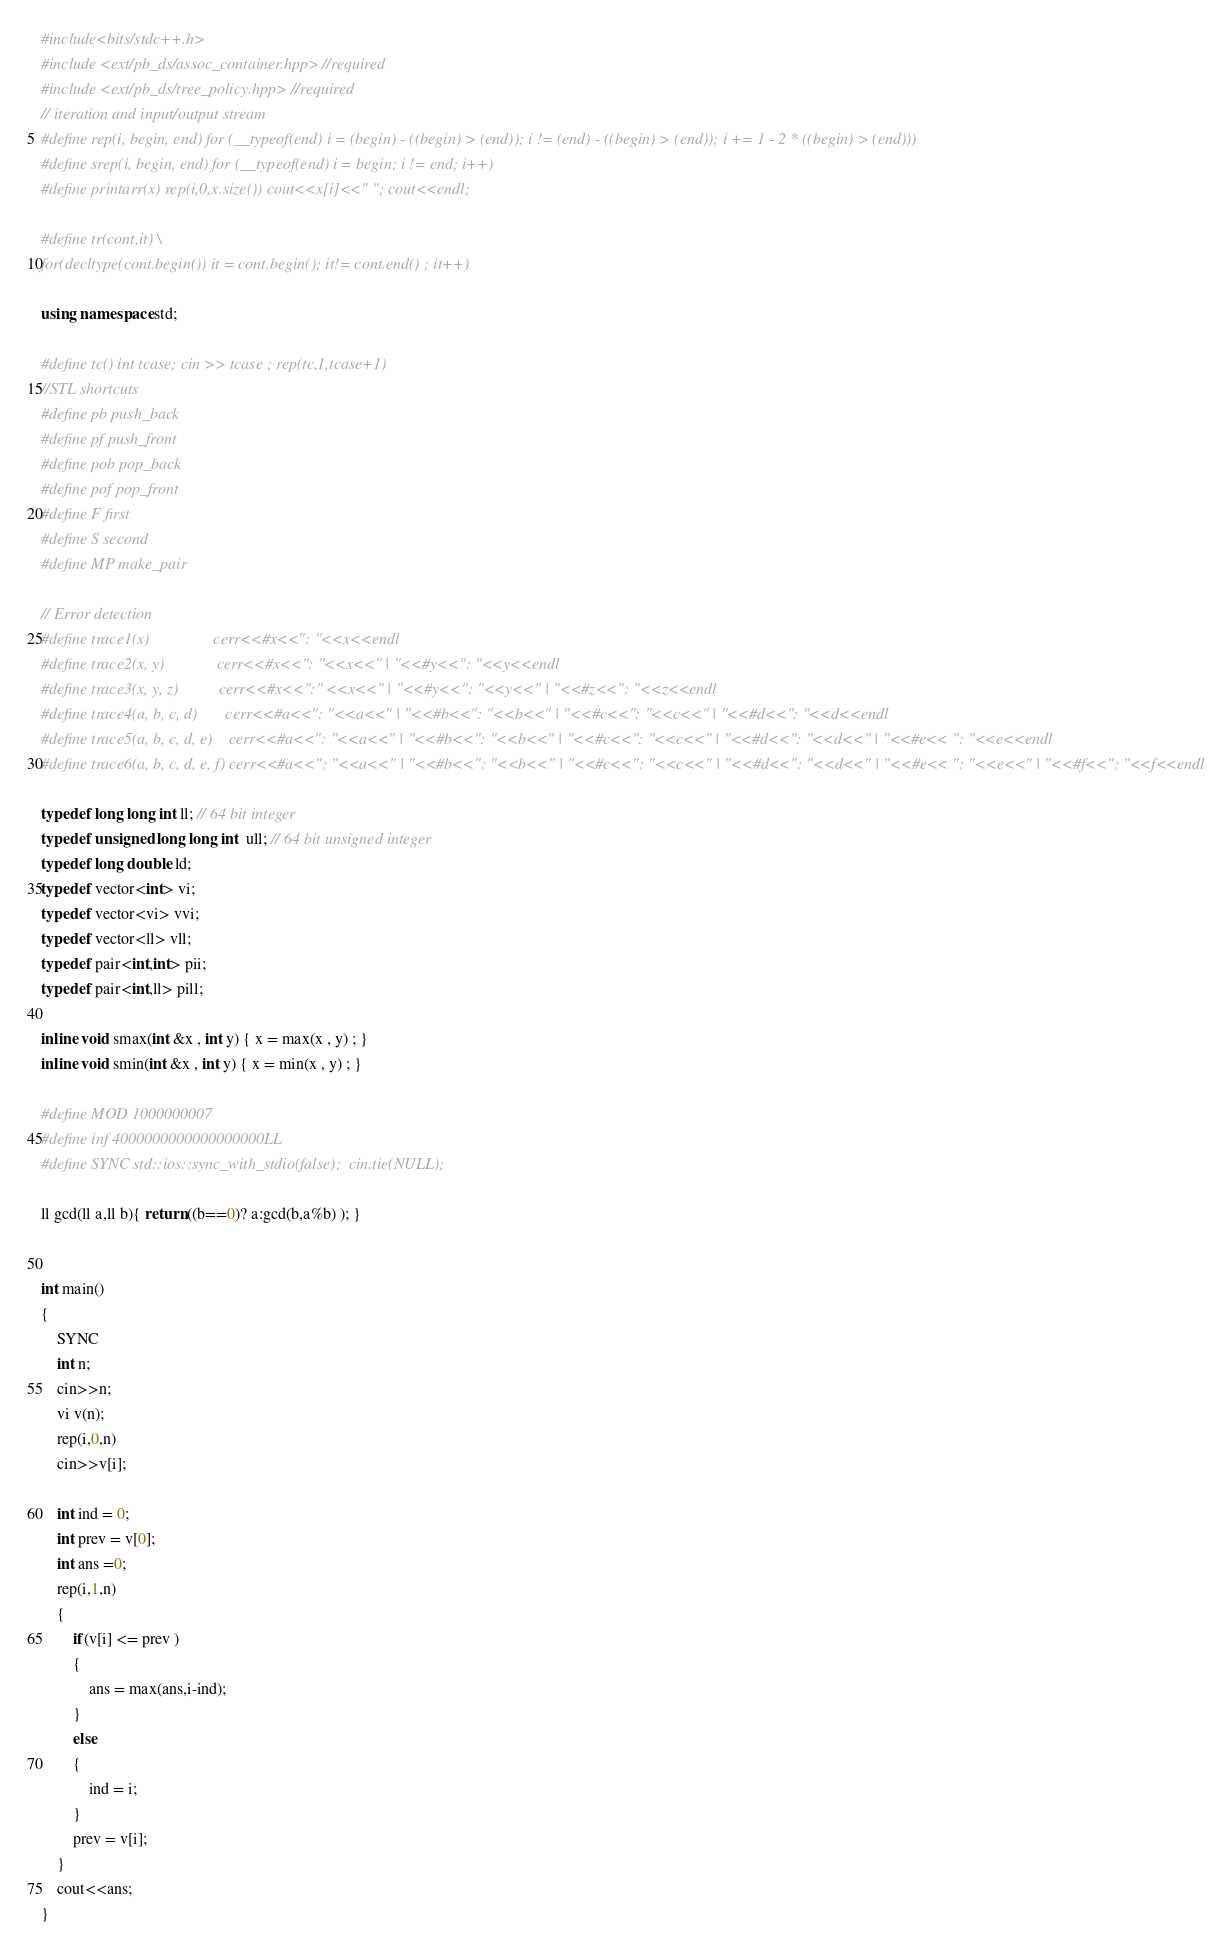<code> <loc_0><loc_0><loc_500><loc_500><_C++_>#include<bits/stdc++.h>
#include <ext/pb_ds/assoc_container.hpp> //required
#include <ext/pb_ds/tree_policy.hpp> //required
// iteration and input/output stream
#define rep(i, begin, end) for (__typeof(end) i = (begin) - ((begin) > (end)); i != (end) - ((begin) > (end)); i += 1 - 2 * ((begin) > (end)))
#define srep(i, begin, end) for (__typeof(end) i = begin; i != end; i++)
#define printarr(x) rep(i,0,x.size()) cout<<x[i]<<" "; cout<<endl;

#define tr(cont,it) \
for(decltype(cont.begin()) it = cont.begin(); it!= cont.end() ; it++)

using namespace std;

#define tc() int tcase; cin >> tcase ; rep(tc,1,tcase+1)
//STL shortcuts
#define pb push_back
#define pf push_front
#define pob pop_back
#define pof pop_front
#define F first
#define S second
#define MP make_pair

// Error detection
#define trace1(x)                cerr<<#x<<": "<<x<<endl
#define trace2(x, y)             cerr<<#x<<": "<<x<<" | "<<#y<<": "<<y<<endl
#define trace3(x, y, z)          cerr<<#x<<":" <<x<<" | "<<#y<<": "<<y<<" | "<<#z<<": "<<z<<endl
#define trace4(a, b, c, d)       cerr<<#a<<": "<<a<<" | "<<#b<<": "<<b<<" | "<<#c<<": "<<c<<" | "<<#d<<": "<<d<<endl
#define trace5(a, b, c, d, e)    cerr<<#a<<": "<<a<<" | "<<#b<<": "<<b<<" | "<<#c<<": "<<c<<" | "<<#d<<": "<<d<<" | "<<#e<< ": "<<e<<endl
#define trace6(a, b, c, d, e, f) cerr<<#a<<": "<<a<<" | "<<#b<<": "<<b<<" | "<<#c<<": "<<c<<" | "<<#d<<": "<<d<<" | "<<#e<< ": "<<e<<" | "<<#f<<": "<<f<<endl

typedef long long int ll; // 64 bit integer
typedef unsigned long long int  ull; // 64 bit unsigned integer
typedef long double ld;
typedef vector<int> vi;
typedef vector<vi> vvi;
typedef vector<ll> vll;
typedef pair<int,int> pii;
typedef pair<int,ll> pill;

inline void smax(int &x , int y) { x = max(x , y) ; }
inline void smin(int &x , int y) { x = min(x , y) ; }

#define MOD 1000000007
#define inf 4000000000000000000LL
#define SYNC std::ios::sync_with_stdio(false);  cin.tie(NULL);

ll gcd(ll a,ll b){ return ((b==0)? a:gcd(b,a%b) ); }


int main()
{
    SYNC
    int n;
    cin>>n;
    vi v(n);
    rep(i,0,n)
    cin>>v[i];

    int ind = 0;
    int prev = v[0];
    int ans =0;
    rep(i,1,n)
    {
        if(v[i] <= prev )
        {
            ans = max(ans,i-ind);
        }
        else
        {
            ind = i;
        }
        prev = v[i];
    }
    cout<<ans;
}
</code> 